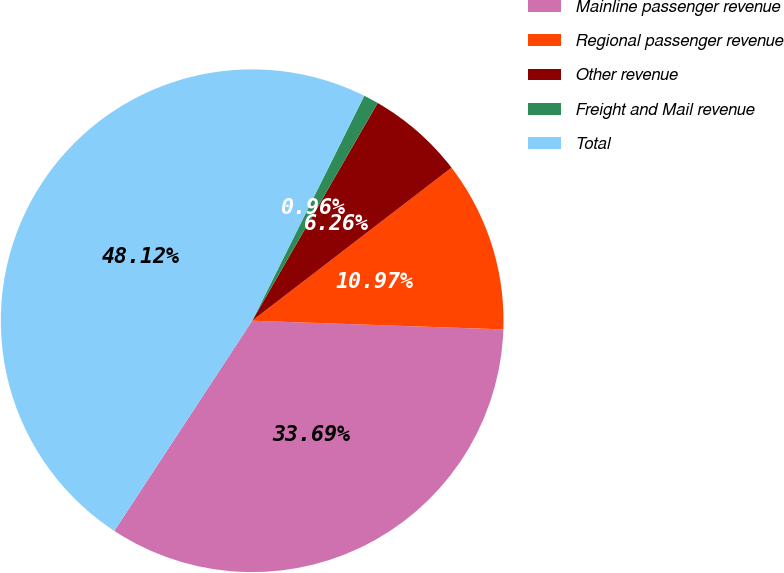Convert chart to OTSL. <chart><loc_0><loc_0><loc_500><loc_500><pie_chart><fcel>Mainline passenger revenue<fcel>Regional passenger revenue<fcel>Other revenue<fcel>Freight and Mail revenue<fcel>Total<nl><fcel>33.69%<fcel>10.97%<fcel>6.26%<fcel>0.96%<fcel>48.12%<nl></chart> 